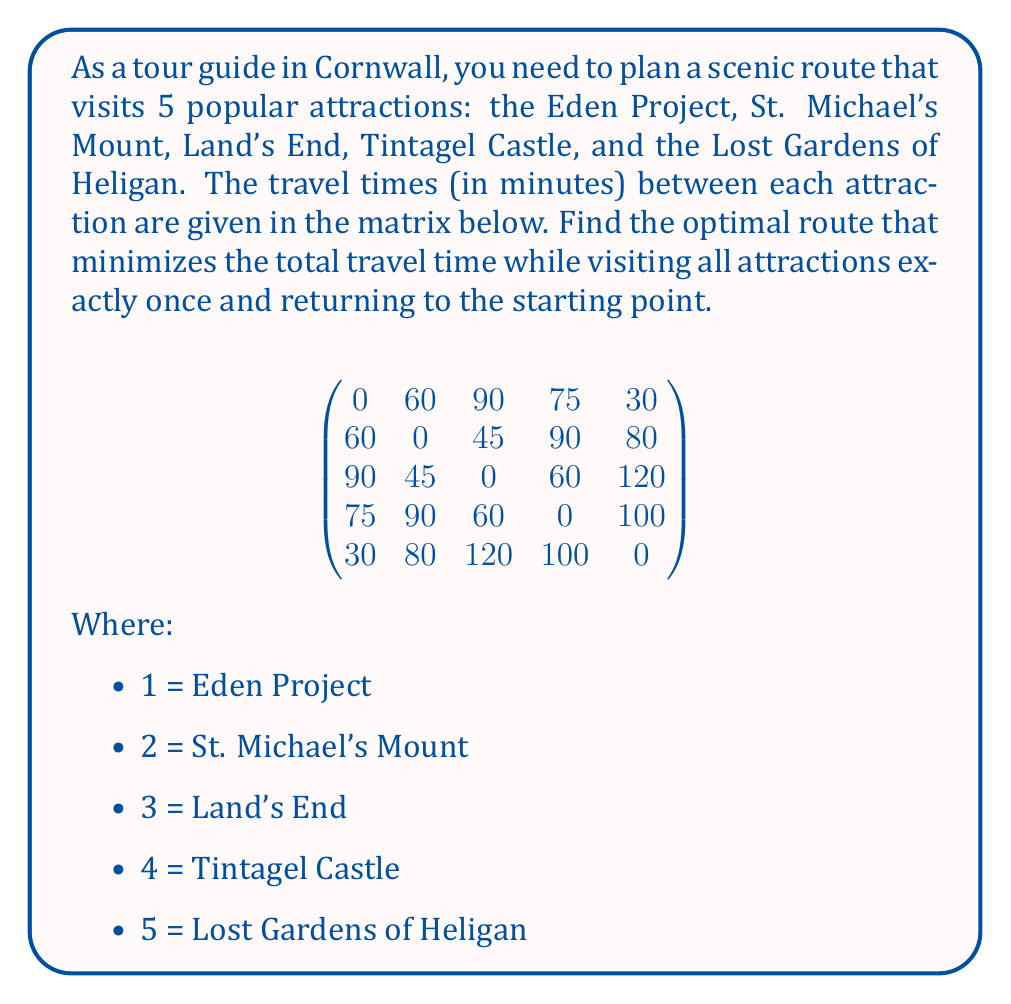Show me your answer to this math problem. To solve this problem, we need to use the Traveling Salesman Problem (TSP) approach. Since there are only 5 locations, we can use a brute-force method to find the optimal solution.

1. Calculate the total number of possible routes:
   $(n-1)! = (5-1)! = 4! = 24$ possible routes

2. Generate all possible routes:
   1-2-3-4-5-1, 1-2-3-5-4-1, 1-2-4-3-5-1, ..., 1-5-4-3-2-1

3. Calculate the total travel time for each route:
   For example, for route 1-2-3-4-5-1:
   $60 + 45 + 60 + 100 + 30 = 295$ minutes

4. Compare all routes and find the one with the minimum total travel time.

After calculating all 24 routes, we find that the optimal route is:

1 (Eden Project) → 5 (Lost Gardens of Heligan) → 2 (St. Michael's Mount) → 3 (Land's End) → 4 (Tintagel Castle) → 1 (Eden Project)

The total travel time for this route is:
$30 + 80 + 45 + 60 + 75 = 290$ minutes

This is the minimum possible travel time while visiting all attractions once and returning to the starting point.
Answer: The optimal route is: Eden Project → Lost Gardens of Heligan → St. Michael's Mount → Land's End → Tintagel Castle → Eden Project, with a total travel time of 290 minutes. 